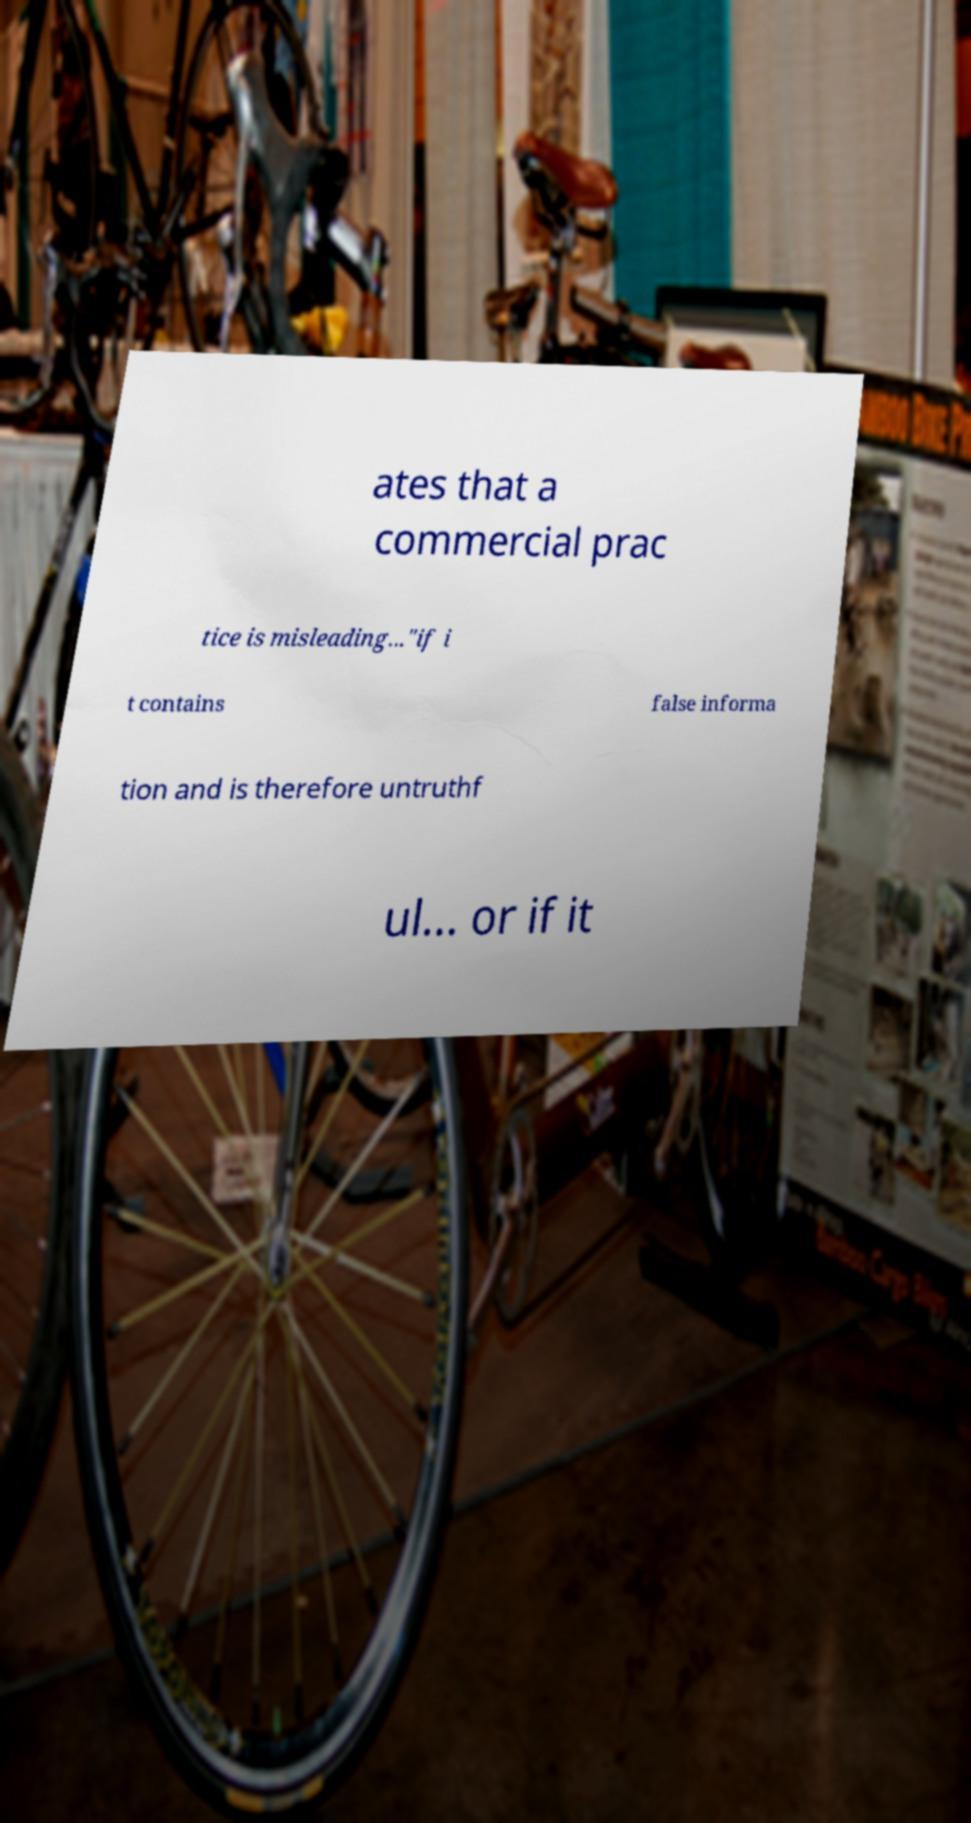Could you extract and type out the text from this image? ates that a commercial prac tice is misleading..."if i t contains false informa tion and is therefore untruthf ul... or if it 